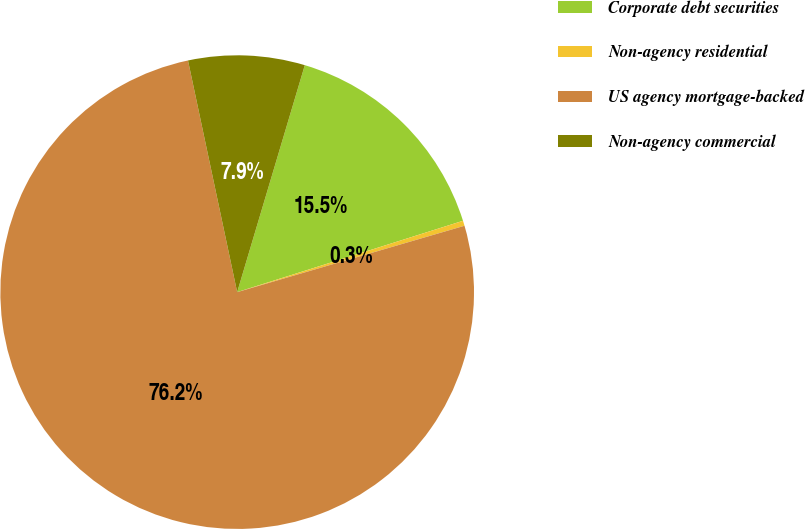Convert chart. <chart><loc_0><loc_0><loc_500><loc_500><pie_chart><fcel>Corporate debt securities<fcel>Non-agency residential<fcel>US agency mortgage-backed<fcel>Non-agency commercial<nl><fcel>15.52%<fcel>0.35%<fcel>76.19%<fcel>7.94%<nl></chart> 